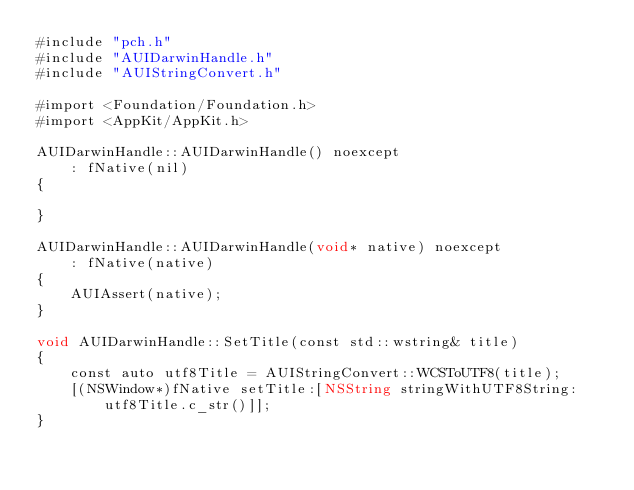Convert code to text. <code><loc_0><loc_0><loc_500><loc_500><_ObjectiveC_>#include "pch.h"
#include "AUIDarwinHandle.h"
#include "AUIStringConvert.h"

#import <Foundation/Foundation.h>
#import <AppKit/AppKit.h>

AUIDarwinHandle::AUIDarwinHandle() noexcept
    : fNative(nil)
{
    
}

AUIDarwinHandle::AUIDarwinHandle(void* native) noexcept
    : fNative(native)
{
    AUIAssert(native);
}

void AUIDarwinHandle::SetTitle(const std::wstring& title)
{
    const auto utf8Title = AUIStringConvert::WCSToUTF8(title);
    [(NSWindow*)fNative setTitle:[NSString stringWithUTF8String:utf8Title.c_str()]];
}
</code> 